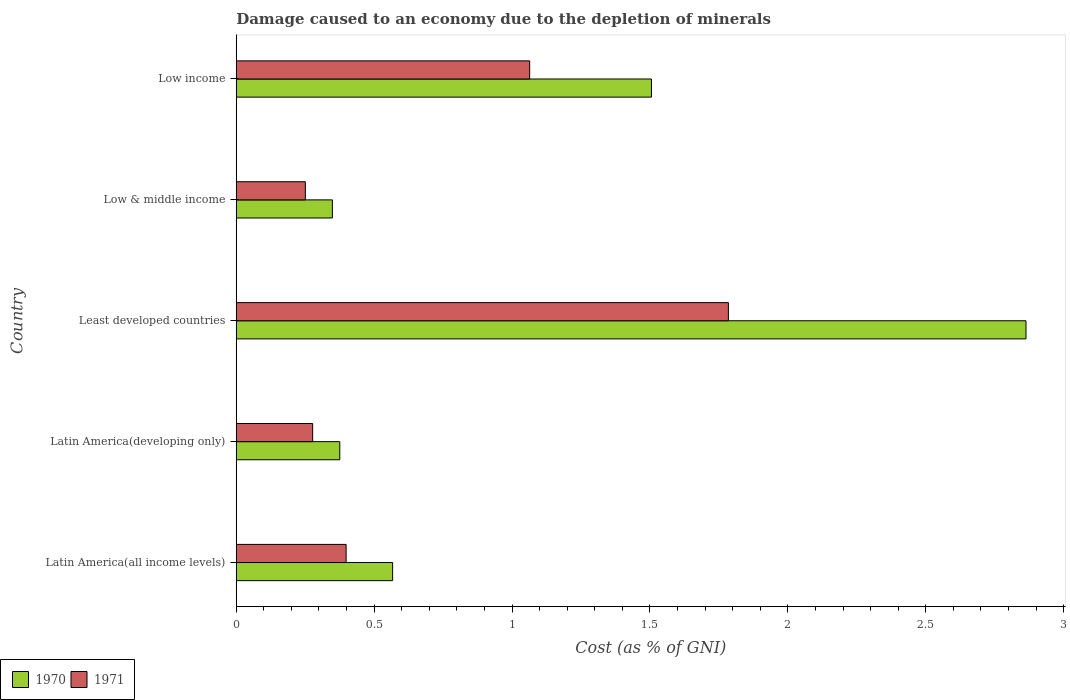How many different coloured bars are there?
Your answer should be very brief. 2. Are the number of bars on each tick of the Y-axis equal?
Provide a short and direct response. Yes. How many bars are there on the 3rd tick from the top?
Give a very brief answer. 2. What is the label of the 3rd group of bars from the top?
Ensure brevity in your answer.  Least developed countries. What is the cost of damage caused due to the depletion of minerals in 1970 in Latin America(developing only)?
Give a very brief answer. 0.38. Across all countries, what is the maximum cost of damage caused due to the depletion of minerals in 1970?
Your response must be concise. 2.86. Across all countries, what is the minimum cost of damage caused due to the depletion of minerals in 1971?
Offer a terse response. 0.25. In which country was the cost of damage caused due to the depletion of minerals in 1970 maximum?
Provide a short and direct response. Least developed countries. What is the total cost of damage caused due to the depletion of minerals in 1971 in the graph?
Make the answer very short. 3.77. What is the difference between the cost of damage caused due to the depletion of minerals in 1971 in Least developed countries and that in Low income?
Your response must be concise. 0.72. What is the difference between the cost of damage caused due to the depletion of minerals in 1970 in Low income and the cost of damage caused due to the depletion of minerals in 1971 in Low & middle income?
Provide a succinct answer. 1.25. What is the average cost of damage caused due to the depletion of minerals in 1970 per country?
Your answer should be compact. 1.13. What is the difference between the cost of damage caused due to the depletion of minerals in 1971 and cost of damage caused due to the depletion of minerals in 1970 in Least developed countries?
Your answer should be very brief. -1.08. In how many countries, is the cost of damage caused due to the depletion of minerals in 1970 greater than 1 %?
Keep it short and to the point. 2. What is the ratio of the cost of damage caused due to the depletion of minerals in 1971 in Latin America(developing only) to that in Low & middle income?
Your response must be concise. 1.11. Is the cost of damage caused due to the depletion of minerals in 1970 in Latin America(developing only) less than that in Low & middle income?
Keep it short and to the point. No. Is the difference between the cost of damage caused due to the depletion of minerals in 1971 in Latin America(developing only) and Least developed countries greater than the difference between the cost of damage caused due to the depletion of minerals in 1970 in Latin America(developing only) and Least developed countries?
Offer a very short reply. Yes. What is the difference between the highest and the second highest cost of damage caused due to the depletion of minerals in 1971?
Provide a succinct answer. 0.72. What is the difference between the highest and the lowest cost of damage caused due to the depletion of minerals in 1971?
Your response must be concise. 1.53. In how many countries, is the cost of damage caused due to the depletion of minerals in 1970 greater than the average cost of damage caused due to the depletion of minerals in 1970 taken over all countries?
Keep it short and to the point. 2. What does the 2nd bar from the top in Least developed countries represents?
Your answer should be compact. 1970. How many bars are there?
Keep it short and to the point. 10. How many countries are there in the graph?
Your answer should be compact. 5. What is the difference between two consecutive major ticks on the X-axis?
Offer a very short reply. 0.5. Does the graph contain any zero values?
Offer a terse response. No. Does the graph contain grids?
Provide a short and direct response. No. What is the title of the graph?
Give a very brief answer. Damage caused to an economy due to the depletion of minerals. Does "1969" appear as one of the legend labels in the graph?
Your response must be concise. No. What is the label or title of the X-axis?
Your answer should be very brief. Cost (as % of GNI). What is the Cost (as % of GNI) in 1970 in Latin America(all income levels)?
Offer a terse response. 0.57. What is the Cost (as % of GNI) of 1971 in Latin America(all income levels)?
Make the answer very short. 0.4. What is the Cost (as % of GNI) of 1970 in Latin America(developing only)?
Give a very brief answer. 0.38. What is the Cost (as % of GNI) of 1971 in Latin America(developing only)?
Make the answer very short. 0.28. What is the Cost (as % of GNI) in 1970 in Least developed countries?
Keep it short and to the point. 2.86. What is the Cost (as % of GNI) in 1971 in Least developed countries?
Make the answer very short. 1.78. What is the Cost (as % of GNI) of 1970 in Low & middle income?
Your answer should be compact. 0.35. What is the Cost (as % of GNI) in 1971 in Low & middle income?
Offer a very short reply. 0.25. What is the Cost (as % of GNI) in 1970 in Low income?
Give a very brief answer. 1.51. What is the Cost (as % of GNI) in 1971 in Low income?
Make the answer very short. 1.06. Across all countries, what is the maximum Cost (as % of GNI) in 1970?
Make the answer very short. 2.86. Across all countries, what is the maximum Cost (as % of GNI) of 1971?
Make the answer very short. 1.78. Across all countries, what is the minimum Cost (as % of GNI) in 1970?
Offer a very short reply. 0.35. Across all countries, what is the minimum Cost (as % of GNI) of 1971?
Your answer should be very brief. 0.25. What is the total Cost (as % of GNI) of 1970 in the graph?
Offer a terse response. 5.66. What is the total Cost (as % of GNI) in 1971 in the graph?
Offer a terse response. 3.77. What is the difference between the Cost (as % of GNI) in 1970 in Latin America(all income levels) and that in Latin America(developing only)?
Your answer should be very brief. 0.19. What is the difference between the Cost (as % of GNI) of 1971 in Latin America(all income levels) and that in Latin America(developing only)?
Your answer should be compact. 0.12. What is the difference between the Cost (as % of GNI) in 1970 in Latin America(all income levels) and that in Least developed countries?
Provide a succinct answer. -2.3. What is the difference between the Cost (as % of GNI) of 1971 in Latin America(all income levels) and that in Least developed countries?
Offer a terse response. -1.39. What is the difference between the Cost (as % of GNI) in 1970 in Latin America(all income levels) and that in Low & middle income?
Offer a terse response. 0.22. What is the difference between the Cost (as % of GNI) in 1971 in Latin America(all income levels) and that in Low & middle income?
Offer a terse response. 0.15. What is the difference between the Cost (as % of GNI) in 1970 in Latin America(all income levels) and that in Low income?
Make the answer very short. -0.94. What is the difference between the Cost (as % of GNI) in 1971 in Latin America(all income levels) and that in Low income?
Your answer should be compact. -0.67. What is the difference between the Cost (as % of GNI) in 1970 in Latin America(developing only) and that in Least developed countries?
Your response must be concise. -2.49. What is the difference between the Cost (as % of GNI) in 1971 in Latin America(developing only) and that in Least developed countries?
Your answer should be compact. -1.51. What is the difference between the Cost (as % of GNI) of 1970 in Latin America(developing only) and that in Low & middle income?
Your answer should be compact. 0.03. What is the difference between the Cost (as % of GNI) of 1971 in Latin America(developing only) and that in Low & middle income?
Provide a short and direct response. 0.03. What is the difference between the Cost (as % of GNI) of 1970 in Latin America(developing only) and that in Low income?
Give a very brief answer. -1.13. What is the difference between the Cost (as % of GNI) of 1971 in Latin America(developing only) and that in Low income?
Your answer should be compact. -0.79. What is the difference between the Cost (as % of GNI) in 1970 in Least developed countries and that in Low & middle income?
Offer a very short reply. 2.52. What is the difference between the Cost (as % of GNI) of 1971 in Least developed countries and that in Low & middle income?
Provide a succinct answer. 1.53. What is the difference between the Cost (as % of GNI) in 1970 in Least developed countries and that in Low income?
Your answer should be compact. 1.36. What is the difference between the Cost (as % of GNI) of 1971 in Least developed countries and that in Low income?
Ensure brevity in your answer.  0.72. What is the difference between the Cost (as % of GNI) of 1970 in Low & middle income and that in Low income?
Your answer should be compact. -1.16. What is the difference between the Cost (as % of GNI) in 1971 in Low & middle income and that in Low income?
Provide a short and direct response. -0.81. What is the difference between the Cost (as % of GNI) of 1970 in Latin America(all income levels) and the Cost (as % of GNI) of 1971 in Latin America(developing only)?
Offer a terse response. 0.29. What is the difference between the Cost (as % of GNI) of 1970 in Latin America(all income levels) and the Cost (as % of GNI) of 1971 in Least developed countries?
Offer a terse response. -1.22. What is the difference between the Cost (as % of GNI) of 1970 in Latin America(all income levels) and the Cost (as % of GNI) of 1971 in Low & middle income?
Your response must be concise. 0.32. What is the difference between the Cost (as % of GNI) in 1970 in Latin America(all income levels) and the Cost (as % of GNI) in 1971 in Low income?
Give a very brief answer. -0.5. What is the difference between the Cost (as % of GNI) of 1970 in Latin America(developing only) and the Cost (as % of GNI) of 1971 in Least developed countries?
Keep it short and to the point. -1.41. What is the difference between the Cost (as % of GNI) of 1970 in Latin America(developing only) and the Cost (as % of GNI) of 1971 in Low & middle income?
Keep it short and to the point. 0.12. What is the difference between the Cost (as % of GNI) in 1970 in Latin America(developing only) and the Cost (as % of GNI) in 1971 in Low income?
Offer a very short reply. -0.69. What is the difference between the Cost (as % of GNI) in 1970 in Least developed countries and the Cost (as % of GNI) in 1971 in Low & middle income?
Ensure brevity in your answer.  2.61. What is the difference between the Cost (as % of GNI) in 1970 in Least developed countries and the Cost (as % of GNI) in 1971 in Low income?
Make the answer very short. 1.8. What is the difference between the Cost (as % of GNI) in 1970 in Low & middle income and the Cost (as % of GNI) in 1971 in Low income?
Make the answer very short. -0.72. What is the average Cost (as % of GNI) of 1970 per country?
Keep it short and to the point. 1.13. What is the average Cost (as % of GNI) of 1971 per country?
Ensure brevity in your answer.  0.75. What is the difference between the Cost (as % of GNI) in 1970 and Cost (as % of GNI) in 1971 in Latin America(all income levels)?
Ensure brevity in your answer.  0.17. What is the difference between the Cost (as % of GNI) in 1970 and Cost (as % of GNI) in 1971 in Latin America(developing only)?
Make the answer very short. 0.1. What is the difference between the Cost (as % of GNI) in 1970 and Cost (as % of GNI) in 1971 in Least developed countries?
Your answer should be very brief. 1.08. What is the difference between the Cost (as % of GNI) in 1970 and Cost (as % of GNI) in 1971 in Low & middle income?
Give a very brief answer. 0.1. What is the difference between the Cost (as % of GNI) in 1970 and Cost (as % of GNI) in 1971 in Low income?
Offer a terse response. 0.44. What is the ratio of the Cost (as % of GNI) in 1970 in Latin America(all income levels) to that in Latin America(developing only)?
Offer a very short reply. 1.51. What is the ratio of the Cost (as % of GNI) in 1971 in Latin America(all income levels) to that in Latin America(developing only)?
Keep it short and to the point. 1.44. What is the ratio of the Cost (as % of GNI) in 1970 in Latin America(all income levels) to that in Least developed countries?
Your response must be concise. 0.2. What is the ratio of the Cost (as % of GNI) of 1971 in Latin America(all income levels) to that in Least developed countries?
Ensure brevity in your answer.  0.22. What is the ratio of the Cost (as % of GNI) of 1970 in Latin America(all income levels) to that in Low & middle income?
Provide a short and direct response. 1.63. What is the ratio of the Cost (as % of GNI) of 1971 in Latin America(all income levels) to that in Low & middle income?
Make the answer very short. 1.59. What is the ratio of the Cost (as % of GNI) of 1970 in Latin America(all income levels) to that in Low income?
Offer a terse response. 0.38. What is the ratio of the Cost (as % of GNI) in 1971 in Latin America(all income levels) to that in Low income?
Offer a very short reply. 0.37. What is the ratio of the Cost (as % of GNI) of 1970 in Latin America(developing only) to that in Least developed countries?
Your response must be concise. 0.13. What is the ratio of the Cost (as % of GNI) in 1971 in Latin America(developing only) to that in Least developed countries?
Provide a succinct answer. 0.16. What is the ratio of the Cost (as % of GNI) in 1970 in Latin America(developing only) to that in Low & middle income?
Offer a terse response. 1.08. What is the ratio of the Cost (as % of GNI) of 1971 in Latin America(developing only) to that in Low & middle income?
Offer a very short reply. 1.11. What is the ratio of the Cost (as % of GNI) in 1970 in Latin America(developing only) to that in Low income?
Your response must be concise. 0.25. What is the ratio of the Cost (as % of GNI) of 1971 in Latin America(developing only) to that in Low income?
Your response must be concise. 0.26. What is the ratio of the Cost (as % of GNI) in 1970 in Least developed countries to that in Low & middle income?
Provide a short and direct response. 8.22. What is the ratio of the Cost (as % of GNI) in 1971 in Least developed countries to that in Low & middle income?
Provide a short and direct response. 7.12. What is the ratio of the Cost (as % of GNI) of 1970 in Least developed countries to that in Low income?
Your answer should be very brief. 1.9. What is the ratio of the Cost (as % of GNI) in 1971 in Least developed countries to that in Low income?
Your answer should be very brief. 1.68. What is the ratio of the Cost (as % of GNI) of 1970 in Low & middle income to that in Low income?
Provide a succinct answer. 0.23. What is the ratio of the Cost (as % of GNI) of 1971 in Low & middle income to that in Low income?
Keep it short and to the point. 0.24. What is the difference between the highest and the second highest Cost (as % of GNI) of 1970?
Ensure brevity in your answer.  1.36. What is the difference between the highest and the second highest Cost (as % of GNI) in 1971?
Your answer should be compact. 0.72. What is the difference between the highest and the lowest Cost (as % of GNI) of 1970?
Give a very brief answer. 2.52. What is the difference between the highest and the lowest Cost (as % of GNI) in 1971?
Ensure brevity in your answer.  1.53. 